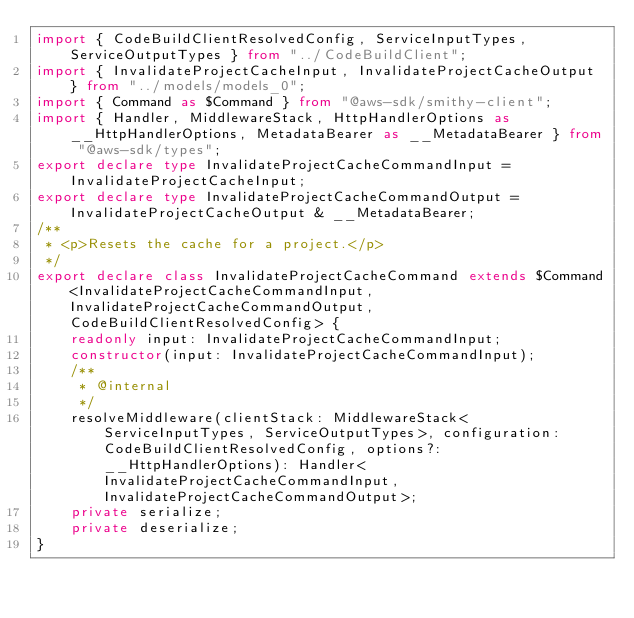<code> <loc_0><loc_0><loc_500><loc_500><_TypeScript_>import { CodeBuildClientResolvedConfig, ServiceInputTypes, ServiceOutputTypes } from "../CodeBuildClient";
import { InvalidateProjectCacheInput, InvalidateProjectCacheOutput } from "../models/models_0";
import { Command as $Command } from "@aws-sdk/smithy-client";
import { Handler, MiddlewareStack, HttpHandlerOptions as __HttpHandlerOptions, MetadataBearer as __MetadataBearer } from "@aws-sdk/types";
export declare type InvalidateProjectCacheCommandInput = InvalidateProjectCacheInput;
export declare type InvalidateProjectCacheCommandOutput = InvalidateProjectCacheOutput & __MetadataBearer;
/**
 * <p>Resets the cache for a project.</p>
 */
export declare class InvalidateProjectCacheCommand extends $Command<InvalidateProjectCacheCommandInput, InvalidateProjectCacheCommandOutput, CodeBuildClientResolvedConfig> {
    readonly input: InvalidateProjectCacheCommandInput;
    constructor(input: InvalidateProjectCacheCommandInput);
    /**
     * @internal
     */
    resolveMiddleware(clientStack: MiddlewareStack<ServiceInputTypes, ServiceOutputTypes>, configuration: CodeBuildClientResolvedConfig, options?: __HttpHandlerOptions): Handler<InvalidateProjectCacheCommandInput, InvalidateProjectCacheCommandOutput>;
    private serialize;
    private deserialize;
}
</code> 